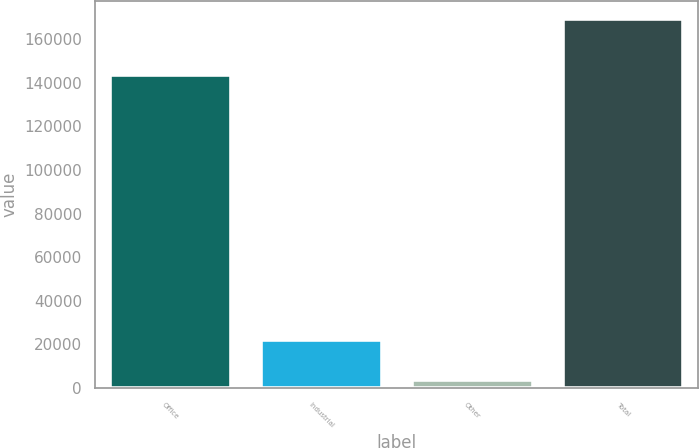<chart> <loc_0><loc_0><loc_500><loc_500><bar_chart><fcel>Office<fcel>Industrial<fcel>Other<fcel>Total<nl><fcel>143567<fcel>21991<fcel>3519<fcel>169077<nl></chart> 